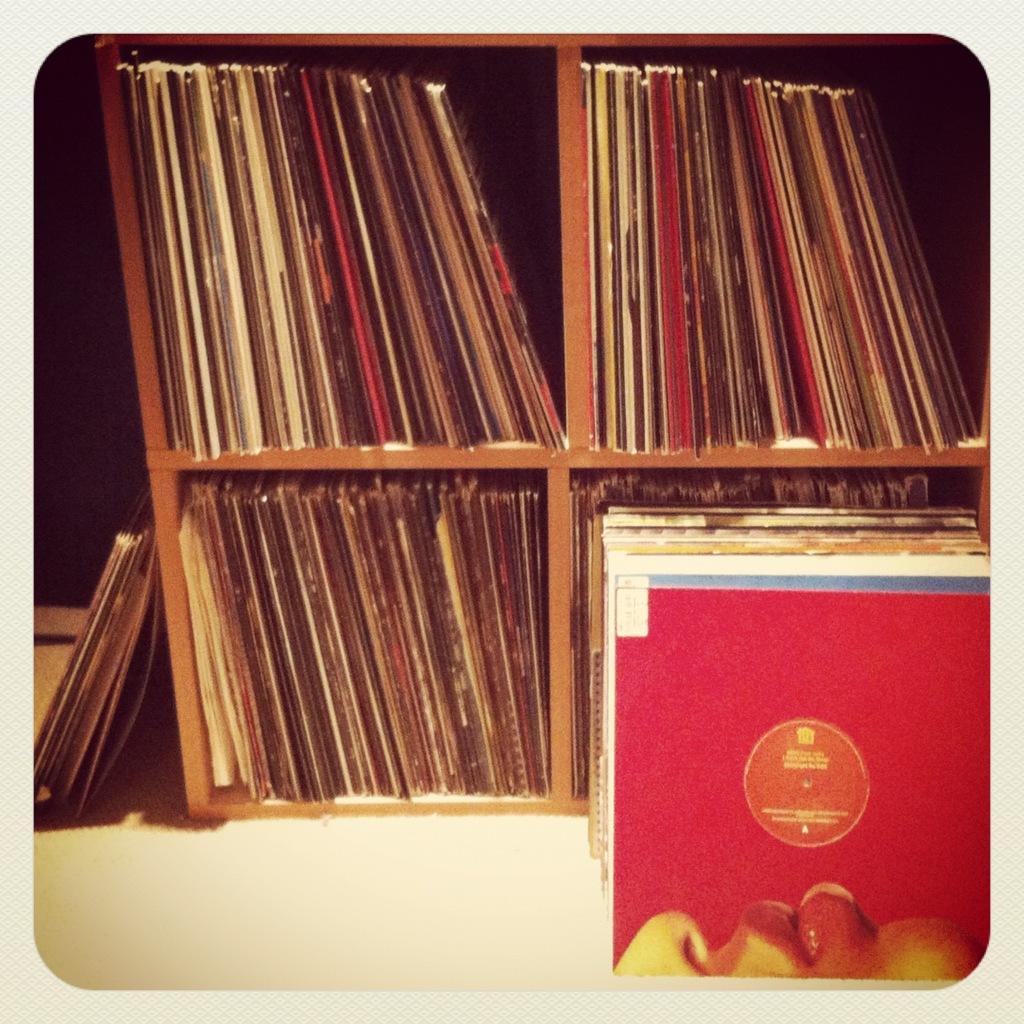Can you describe this image briefly? In the image there are many books kept in the shelves. 